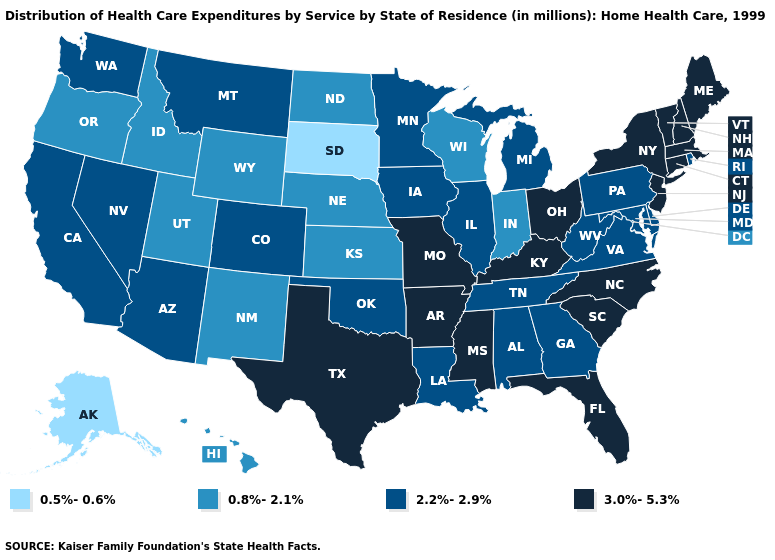Among the states that border Indiana , does Kentucky have the lowest value?
Concise answer only. No. Name the states that have a value in the range 3.0%-5.3%?
Keep it brief. Arkansas, Connecticut, Florida, Kentucky, Maine, Massachusetts, Mississippi, Missouri, New Hampshire, New Jersey, New York, North Carolina, Ohio, South Carolina, Texas, Vermont. Among the states that border Arizona , does Utah have the highest value?
Answer briefly. No. Does the first symbol in the legend represent the smallest category?
Be succinct. Yes. Does New Mexico have a higher value than Washington?
Quick response, please. No. Among the states that border Colorado , does Arizona have the lowest value?
Answer briefly. No. Name the states that have a value in the range 3.0%-5.3%?
Answer briefly. Arkansas, Connecticut, Florida, Kentucky, Maine, Massachusetts, Mississippi, Missouri, New Hampshire, New Jersey, New York, North Carolina, Ohio, South Carolina, Texas, Vermont. What is the value of Colorado?
Write a very short answer. 2.2%-2.9%. What is the highest value in states that border Rhode Island?
Quick response, please. 3.0%-5.3%. Does Arizona have a higher value than Missouri?
Answer briefly. No. Among the states that border North Carolina , which have the highest value?
Concise answer only. South Carolina. What is the lowest value in the USA?
Keep it brief. 0.5%-0.6%. What is the value of Vermont?
Answer briefly. 3.0%-5.3%. What is the highest value in states that border Oregon?
Concise answer only. 2.2%-2.9%. 